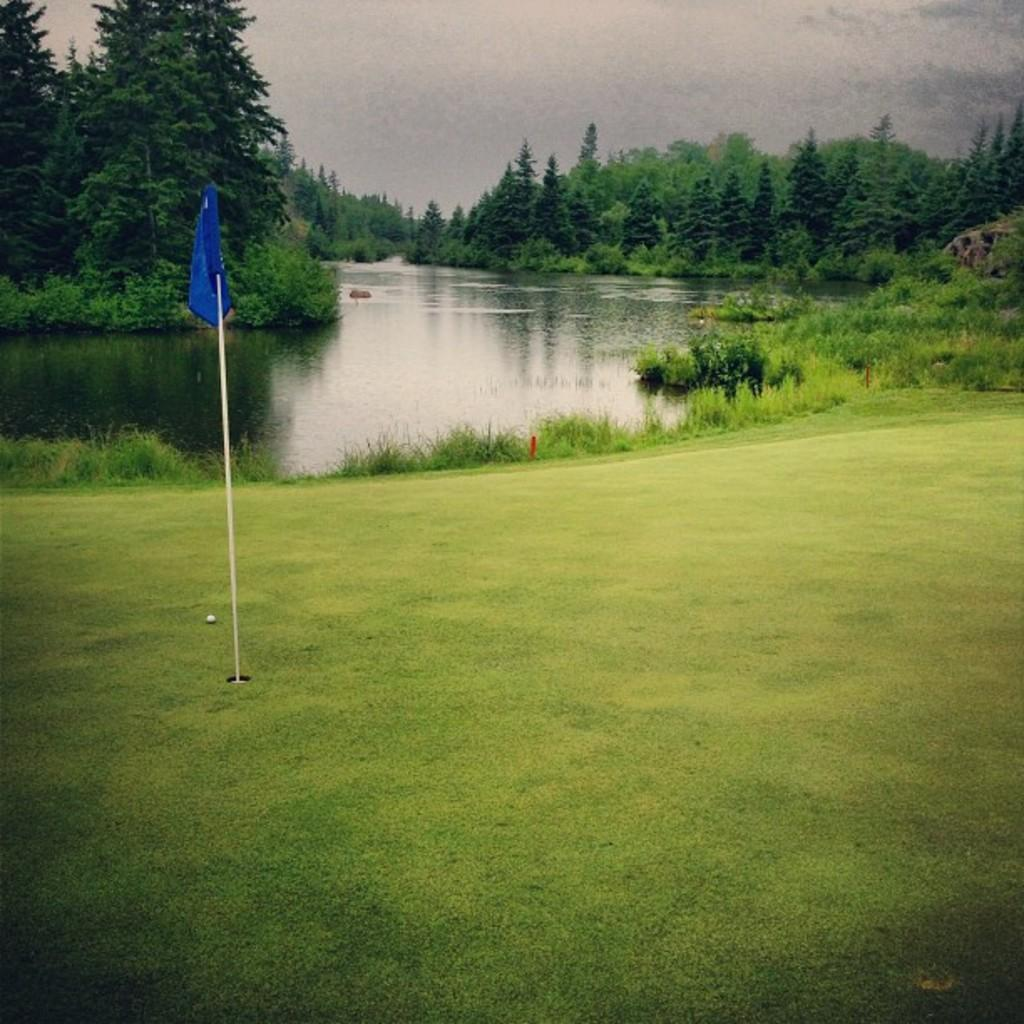What type of vegetation can be seen in the image? There is grass, plants, and trees visible in the image. What is attached to the pole in the image? There is a flag attached to the pole in the image. What can be seen in the background of the image? The sky is visible in the background of the image, and there are clouds in the sky. What is the primary source of water visible in the image? There is water visible in the image, but it is not specified what type of water source it is. What scientific experiment is being conducted in the image? There is no indication of a scientific experiment being conducted in the image. How many doors are visible in the image? There are no doors visible in the image. 